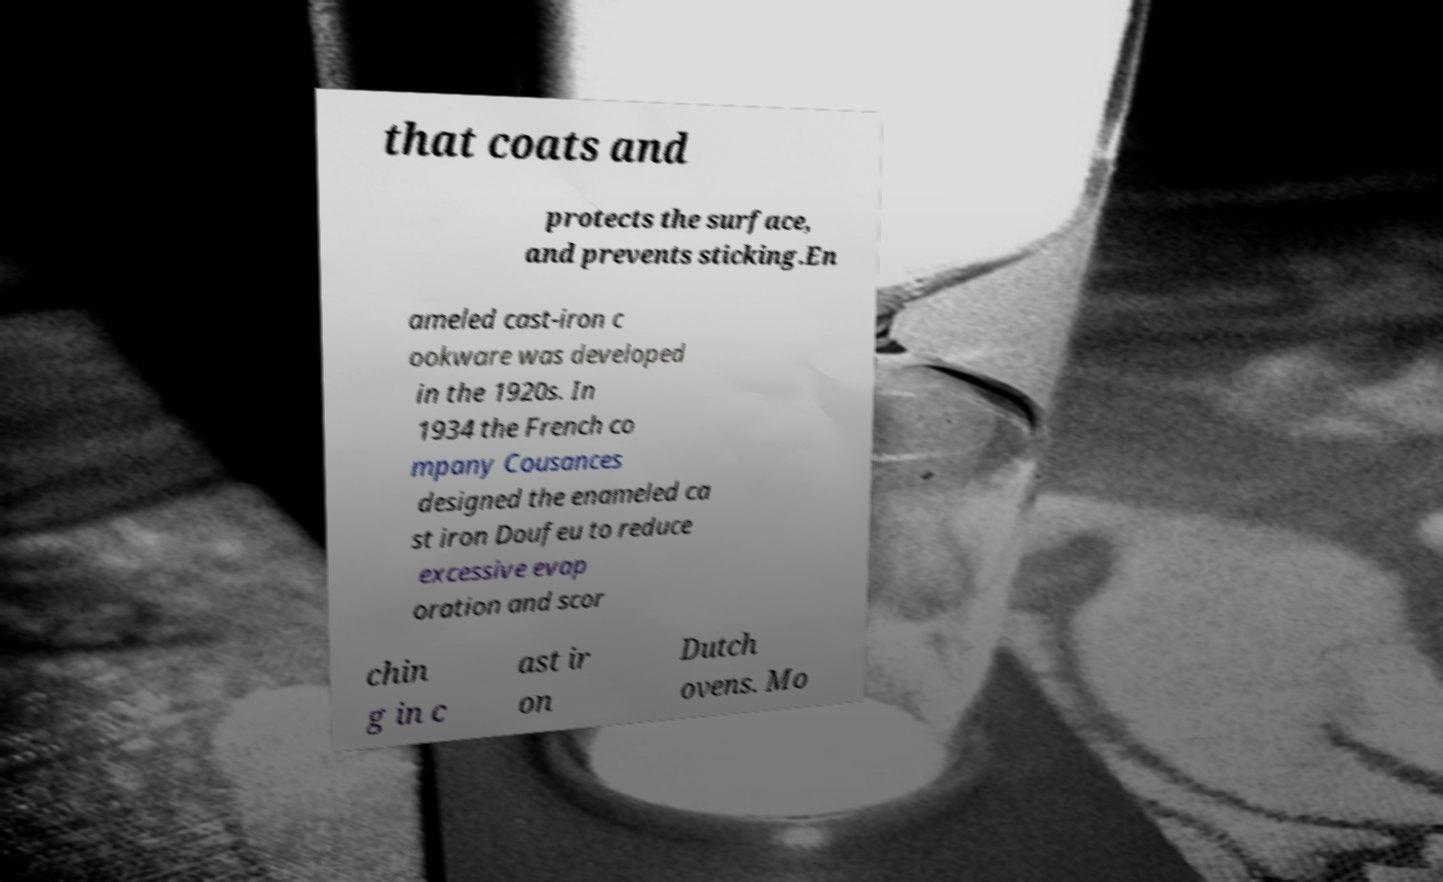For documentation purposes, I need the text within this image transcribed. Could you provide that? that coats and protects the surface, and prevents sticking.En ameled cast-iron c ookware was developed in the 1920s. In 1934 the French co mpany Cousances designed the enameled ca st iron Doufeu to reduce excessive evap oration and scor chin g in c ast ir on Dutch ovens. Mo 